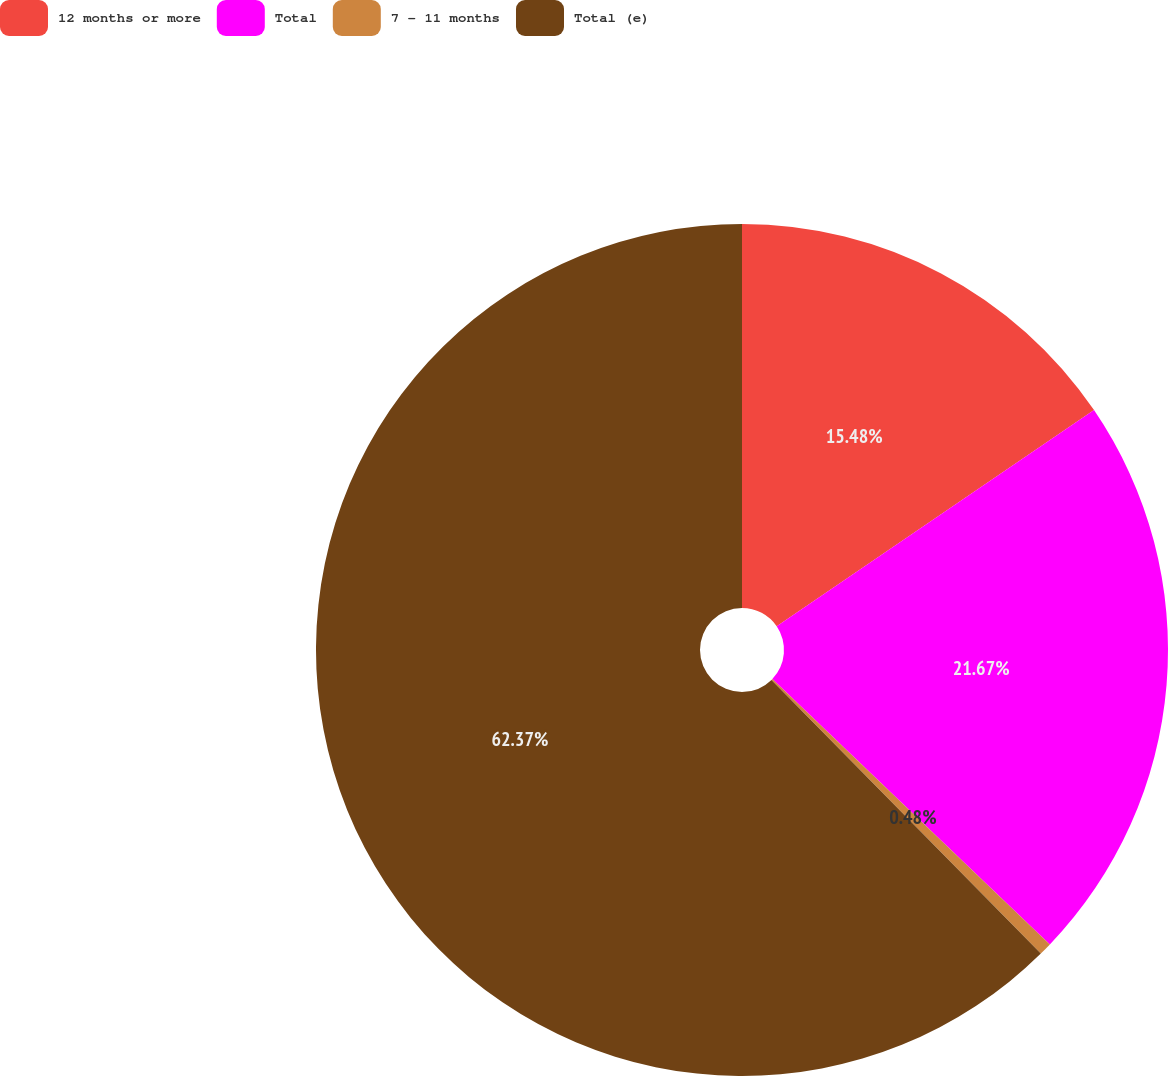Convert chart to OTSL. <chart><loc_0><loc_0><loc_500><loc_500><pie_chart><fcel>12 months or more<fcel>Total<fcel>7 - 11 months<fcel>Total (e)<nl><fcel>15.48%<fcel>21.67%<fcel>0.48%<fcel>62.38%<nl></chart> 